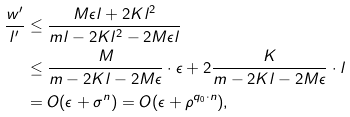Convert formula to latex. <formula><loc_0><loc_0><loc_500><loc_500>\frac { w ^ { \prime } } { l ^ { \prime } } & \leq \frac { M \epsilon l + 2 K l ^ { 2 } } { m l - 2 K l ^ { 2 } - 2 M \epsilon l } \\ & \leq \frac { M } { m - 2 K l - 2 M \epsilon } \cdot \epsilon + 2 \frac { K } { m - 2 K l - 2 M \epsilon } \cdot l \\ & = O ( \epsilon + \sigma ^ { n } ) = O ( \epsilon + \rho ^ { q _ { 0 } \cdot n } ) ,</formula> 